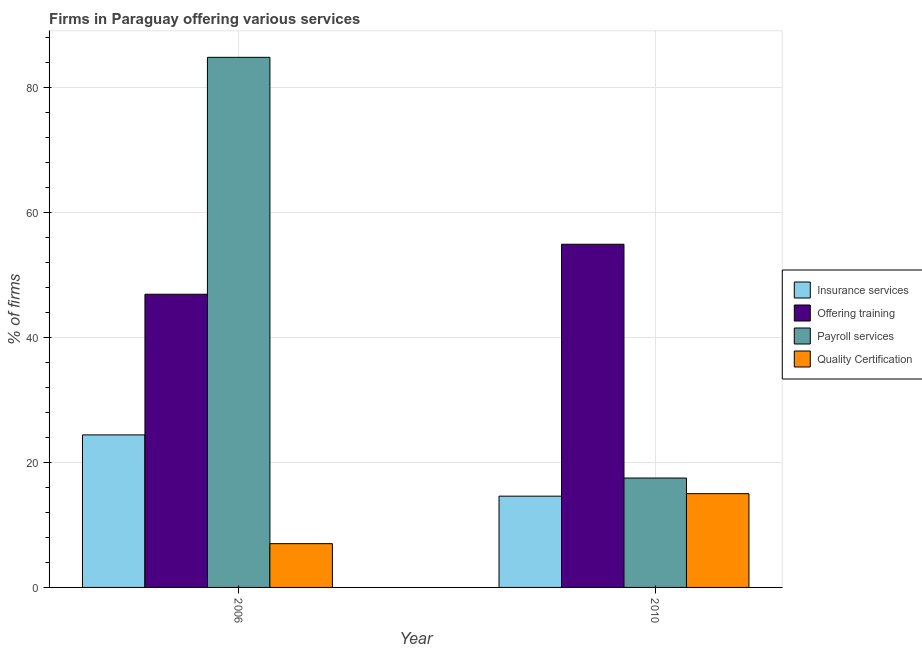How many different coloured bars are there?
Provide a short and direct response. 4. How many groups of bars are there?
Your answer should be compact. 2. What is the percentage of firms offering payroll services in 2006?
Make the answer very short. 84.8. Across all years, what is the maximum percentage of firms offering training?
Your answer should be very brief. 54.9. Across all years, what is the minimum percentage of firms offering training?
Ensure brevity in your answer.  46.9. In which year was the percentage of firms offering insurance services maximum?
Make the answer very short. 2006. What is the total percentage of firms offering payroll services in the graph?
Offer a very short reply. 102.3. What is the difference between the percentage of firms offering quality certification in 2006 and that in 2010?
Provide a succinct answer. -8. What is the difference between the percentage of firms offering payroll services in 2010 and the percentage of firms offering quality certification in 2006?
Offer a very short reply. -67.3. In the year 2006, what is the difference between the percentage of firms offering payroll services and percentage of firms offering quality certification?
Provide a short and direct response. 0. In how many years, is the percentage of firms offering payroll services greater than 4 %?
Offer a terse response. 2. What is the ratio of the percentage of firms offering insurance services in 2006 to that in 2010?
Give a very brief answer. 1.67. Is the percentage of firms offering payroll services in 2006 less than that in 2010?
Your answer should be compact. No. What does the 2nd bar from the left in 2006 represents?
Offer a terse response. Offering training. What does the 4th bar from the right in 2010 represents?
Provide a short and direct response. Insurance services. Is it the case that in every year, the sum of the percentage of firms offering insurance services and percentage of firms offering training is greater than the percentage of firms offering payroll services?
Ensure brevity in your answer.  No. Are all the bars in the graph horizontal?
Provide a succinct answer. No. What is the difference between two consecutive major ticks on the Y-axis?
Make the answer very short. 20. Does the graph contain grids?
Your answer should be very brief. Yes. Where does the legend appear in the graph?
Provide a short and direct response. Center right. How are the legend labels stacked?
Offer a terse response. Vertical. What is the title of the graph?
Offer a very short reply. Firms in Paraguay offering various services . What is the label or title of the Y-axis?
Offer a very short reply. % of firms. What is the % of firms in Insurance services in 2006?
Offer a terse response. 24.4. What is the % of firms of Offering training in 2006?
Your answer should be compact. 46.9. What is the % of firms in Payroll services in 2006?
Ensure brevity in your answer.  84.8. What is the % of firms of Quality Certification in 2006?
Provide a succinct answer. 7. What is the % of firms of Insurance services in 2010?
Your response must be concise. 14.6. What is the % of firms in Offering training in 2010?
Keep it short and to the point. 54.9. Across all years, what is the maximum % of firms in Insurance services?
Your answer should be very brief. 24.4. Across all years, what is the maximum % of firms of Offering training?
Offer a terse response. 54.9. Across all years, what is the maximum % of firms in Payroll services?
Give a very brief answer. 84.8. Across all years, what is the maximum % of firms in Quality Certification?
Provide a succinct answer. 15. Across all years, what is the minimum % of firms of Offering training?
Give a very brief answer. 46.9. Across all years, what is the minimum % of firms in Payroll services?
Your response must be concise. 17.5. What is the total % of firms in Offering training in the graph?
Give a very brief answer. 101.8. What is the total % of firms of Payroll services in the graph?
Provide a succinct answer. 102.3. What is the total % of firms of Quality Certification in the graph?
Provide a short and direct response. 22. What is the difference between the % of firms of Payroll services in 2006 and that in 2010?
Provide a short and direct response. 67.3. What is the difference between the % of firms in Quality Certification in 2006 and that in 2010?
Offer a very short reply. -8. What is the difference between the % of firms of Insurance services in 2006 and the % of firms of Offering training in 2010?
Offer a terse response. -30.5. What is the difference between the % of firms of Insurance services in 2006 and the % of firms of Quality Certification in 2010?
Offer a very short reply. 9.4. What is the difference between the % of firms in Offering training in 2006 and the % of firms in Payroll services in 2010?
Keep it short and to the point. 29.4. What is the difference between the % of firms of Offering training in 2006 and the % of firms of Quality Certification in 2010?
Offer a terse response. 31.9. What is the difference between the % of firms in Payroll services in 2006 and the % of firms in Quality Certification in 2010?
Provide a succinct answer. 69.8. What is the average % of firms in Offering training per year?
Your answer should be very brief. 50.9. What is the average % of firms in Payroll services per year?
Keep it short and to the point. 51.15. In the year 2006, what is the difference between the % of firms of Insurance services and % of firms of Offering training?
Offer a terse response. -22.5. In the year 2006, what is the difference between the % of firms of Insurance services and % of firms of Payroll services?
Your response must be concise. -60.4. In the year 2006, what is the difference between the % of firms of Insurance services and % of firms of Quality Certification?
Offer a terse response. 17.4. In the year 2006, what is the difference between the % of firms in Offering training and % of firms in Payroll services?
Ensure brevity in your answer.  -37.9. In the year 2006, what is the difference between the % of firms in Offering training and % of firms in Quality Certification?
Your answer should be very brief. 39.9. In the year 2006, what is the difference between the % of firms of Payroll services and % of firms of Quality Certification?
Provide a succinct answer. 77.8. In the year 2010, what is the difference between the % of firms of Insurance services and % of firms of Offering training?
Your answer should be very brief. -40.3. In the year 2010, what is the difference between the % of firms in Offering training and % of firms in Payroll services?
Your answer should be compact. 37.4. In the year 2010, what is the difference between the % of firms in Offering training and % of firms in Quality Certification?
Give a very brief answer. 39.9. In the year 2010, what is the difference between the % of firms in Payroll services and % of firms in Quality Certification?
Keep it short and to the point. 2.5. What is the ratio of the % of firms of Insurance services in 2006 to that in 2010?
Make the answer very short. 1.67. What is the ratio of the % of firms of Offering training in 2006 to that in 2010?
Your answer should be compact. 0.85. What is the ratio of the % of firms in Payroll services in 2006 to that in 2010?
Your answer should be very brief. 4.85. What is the ratio of the % of firms of Quality Certification in 2006 to that in 2010?
Offer a terse response. 0.47. What is the difference between the highest and the second highest % of firms of Insurance services?
Make the answer very short. 9.8. What is the difference between the highest and the second highest % of firms of Offering training?
Your answer should be compact. 8. What is the difference between the highest and the second highest % of firms of Payroll services?
Your response must be concise. 67.3. What is the difference between the highest and the second highest % of firms in Quality Certification?
Make the answer very short. 8. What is the difference between the highest and the lowest % of firms of Offering training?
Make the answer very short. 8. What is the difference between the highest and the lowest % of firms of Payroll services?
Make the answer very short. 67.3. 